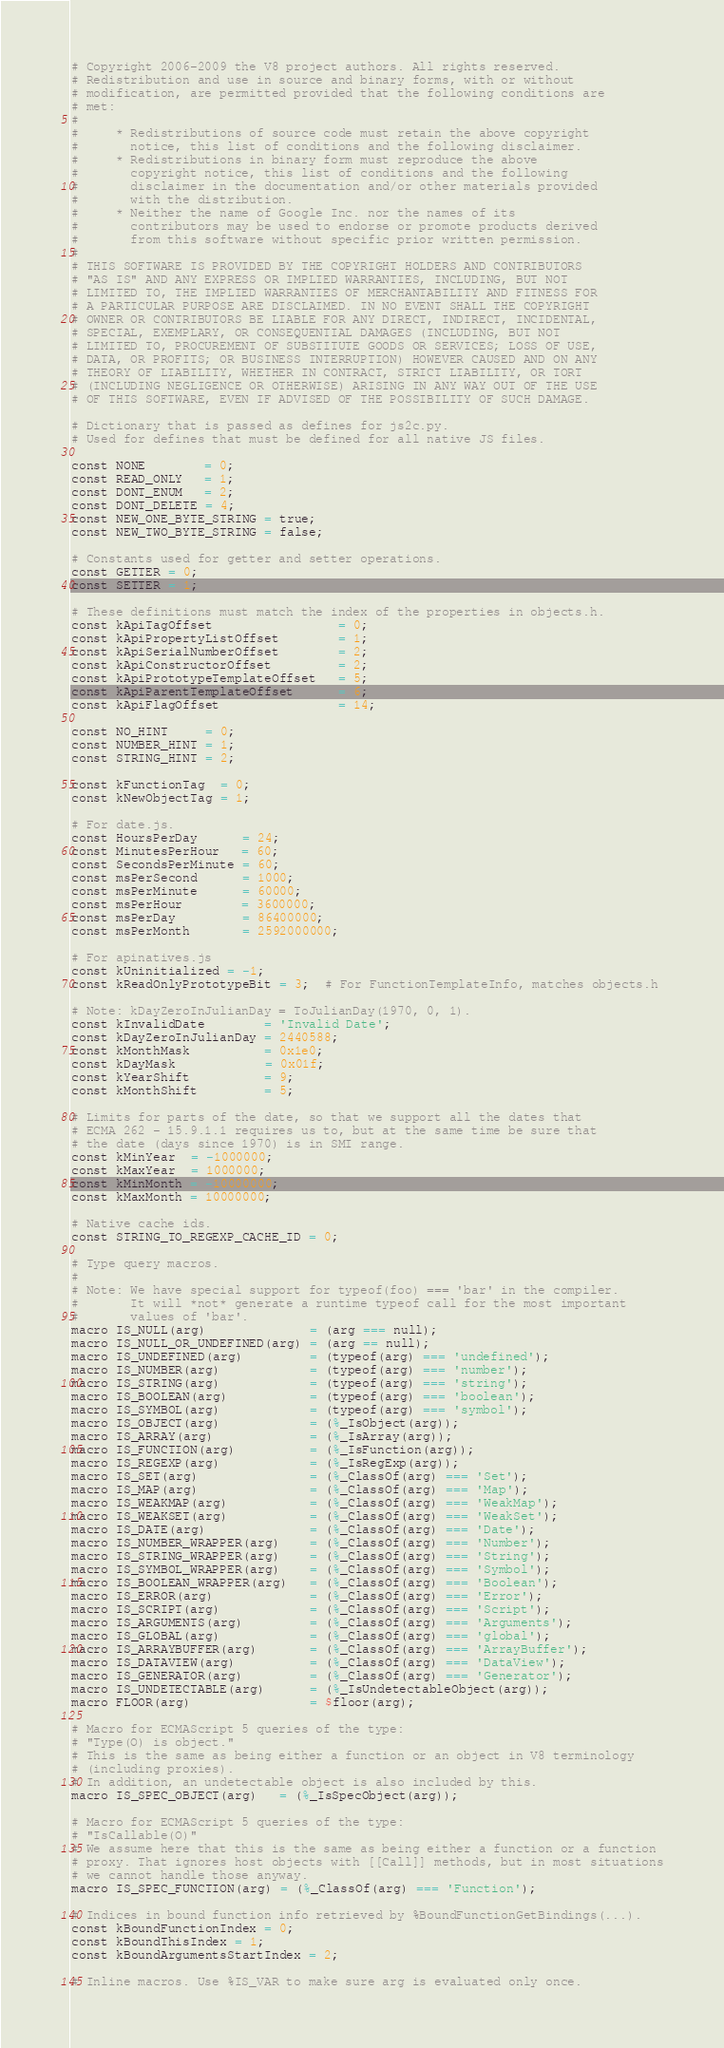<code> <loc_0><loc_0><loc_500><loc_500><_Python_># Copyright 2006-2009 the V8 project authors. All rights reserved.
# Redistribution and use in source and binary forms, with or without
# modification, are permitted provided that the following conditions are
# met:
#
#     * Redistributions of source code must retain the above copyright
#       notice, this list of conditions and the following disclaimer.
#     * Redistributions in binary form must reproduce the above
#       copyright notice, this list of conditions and the following
#       disclaimer in the documentation and/or other materials provided
#       with the distribution.
#     * Neither the name of Google Inc. nor the names of its
#       contributors may be used to endorse or promote products derived
#       from this software without specific prior written permission.
#
# THIS SOFTWARE IS PROVIDED BY THE COPYRIGHT HOLDERS AND CONTRIBUTORS
# "AS IS" AND ANY EXPRESS OR IMPLIED WARRANTIES, INCLUDING, BUT NOT
# LIMITED TO, THE IMPLIED WARRANTIES OF MERCHANTABILITY AND FITNESS FOR
# A PARTICULAR PURPOSE ARE DISCLAIMED. IN NO EVENT SHALL THE COPYRIGHT
# OWNER OR CONTRIBUTORS BE LIABLE FOR ANY DIRECT, INDIRECT, INCIDENTAL,
# SPECIAL, EXEMPLARY, OR CONSEQUENTIAL DAMAGES (INCLUDING, BUT NOT
# LIMITED TO, PROCUREMENT OF SUBSTITUTE GOODS OR SERVICES; LOSS OF USE,
# DATA, OR PROFITS; OR BUSINESS INTERRUPTION) HOWEVER CAUSED AND ON ANY
# THEORY OF LIABILITY, WHETHER IN CONTRACT, STRICT LIABILITY, OR TORT
# (INCLUDING NEGLIGENCE OR OTHERWISE) ARISING IN ANY WAY OUT OF THE USE
# OF THIS SOFTWARE, EVEN IF ADVISED OF THE POSSIBILITY OF SUCH DAMAGE.

# Dictionary that is passed as defines for js2c.py.
# Used for defines that must be defined for all native JS files.

const NONE        = 0;
const READ_ONLY   = 1;
const DONT_ENUM   = 2;
const DONT_DELETE = 4;
const NEW_ONE_BYTE_STRING = true;
const NEW_TWO_BYTE_STRING = false;

# Constants used for getter and setter operations.
const GETTER = 0;
const SETTER = 1;

# These definitions must match the index of the properties in objects.h.
const kApiTagOffset                 = 0;
const kApiPropertyListOffset        = 1;
const kApiSerialNumberOffset        = 2;
const kApiConstructorOffset         = 2;
const kApiPrototypeTemplateOffset   = 5;
const kApiParentTemplateOffset      = 6;
const kApiFlagOffset                = 14;

const NO_HINT     = 0;
const NUMBER_HINT = 1;
const STRING_HINT = 2;

const kFunctionTag  = 0;
const kNewObjectTag = 1;

# For date.js.
const HoursPerDay      = 24;
const MinutesPerHour   = 60;
const SecondsPerMinute = 60;
const msPerSecond      = 1000;
const msPerMinute      = 60000;
const msPerHour        = 3600000;
const msPerDay         = 86400000;
const msPerMonth       = 2592000000;

# For apinatives.js
const kUninitialized = -1;
const kReadOnlyPrototypeBit = 3;  # For FunctionTemplateInfo, matches objects.h

# Note: kDayZeroInJulianDay = ToJulianDay(1970, 0, 1).
const kInvalidDate        = 'Invalid Date';
const kDayZeroInJulianDay = 2440588;
const kMonthMask          = 0x1e0;
const kDayMask            = 0x01f;
const kYearShift          = 9;
const kMonthShift         = 5;

# Limits for parts of the date, so that we support all the dates that
# ECMA 262 - 15.9.1.1 requires us to, but at the same time be sure that
# the date (days since 1970) is in SMI range.
const kMinYear  = -1000000;
const kMaxYear  = 1000000;
const kMinMonth = -10000000;
const kMaxMonth = 10000000;

# Native cache ids.
const STRING_TO_REGEXP_CACHE_ID = 0;

# Type query macros.
#
# Note: We have special support for typeof(foo) === 'bar' in the compiler.
#       It will *not* generate a runtime typeof call for the most important
#       values of 'bar'.
macro IS_NULL(arg)              = (arg === null);
macro IS_NULL_OR_UNDEFINED(arg) = (arg == null);
macro IS_UNDEFINED(arg)         = (typeof(arg) === 'undefined');
macro IS_NUMBER(arg)            = (typeof(arg) === 'number');
macro IS_STRING(arg)            = (typeof(arg) === 'string');
macro IS_BOOLEAN(arg)           = (typeof(arg) === 'boolean');
macro IS_SYMBOL(arg)            = (typeof(arg) === 'symbol');
macro IS_OBJECT(arg)            = (%_IsObject(arg));
macro IS_ARRAY(arg)             = (%_IsArray(arg));
macro IS_FUNCTION(arg)          = (%_IsFunction(arg));
macro IS_REGEXP(arg)            = (%_IsRegExp(arg));
macro IS_SET(arg)               = (%_ClassOf(arg) === 'Set');
macro IS_MAP(arg)               = (%_ClassOf(arg) === 'Map');
macro IS_WEAKMAP(arg)           = (%_ClassOf(arg) === 'WeakMap');
macro IS_WEAKSET(arg)           = (%_ClassOf(arg) === 'WeakSet');
macro IS_DATE(arg)              = (%_ClassOf(arg) === 'Date');
macro IS_NUMBER_WRAPPER(arg)    = (%_ClassOf(arg) === 'Number');
macro IS_STRING_WRAPPER(arg)    = (%_ClassOf(arg) === 'String');
macro IS_SYMBOL_WRAPPER(arg)    = (%_ClassOf(arg) === 'Symbol');
macro IS_BOOLEAN_WRAPPER(arg)   = (%_ClassOf(arg) === 'Boolean');
macro IS_ERROR(arg)             = (%_ClassOf(arg) === 'Error');
macro IS_SCRIPT(arg)            = (%_ClassOf(arg) === 'Script');
macro IS_ARGUMENTS(arg)         = (%_ClassOf(arg) === 'Arguments');
macro IS_GLOBAL(arg)            = (%_ClassOf(arg) === 'global');
macro IS_ARRAYBUFFER(arg)       = (%_ClassOf(arg) === 'ArrayBuffer');
macro IS_DATAVIEW(arg)          = (%_ClassOf(arg) === 'DataView');
macro IS_GENERATOR(arg)         = (%_ClassOf(arg) === 'Generator');
macro IS_UNDETECTABLE(arg)      = (%_IsUndetectableObject(arg));
macro FLOOR(arg)                = $floor(arg);

# Macro for ECMAScript 5 queries of the type:
# "Type(O) is object."
# This is the same as being either a function or an object in V8 terminology
# (including proxies).
# In addition, an undetectable object is also included by this.
macro IS_SPEC_OBJECT(arg)   = (%_IsSpecObject(arg));

# Macro for ECMAScript 5 queries of the type:
# "IsCallable(O)"
# We assume here that this is the same as being either a function or a function
# proxy. That ignores host objects with [[Call]] methods, but in most situations
# we cannot handle those anyway.
macro IS_SPEC_FUNCTION(arg) = (%_ClassOf(arg) === 'Function');

# Indices in bound function info retrieved by %BoundFunctionGetBindings(...).
const kBoundFunctionIndex = 0;
const kBoundThisIndex = 1;
const kBoundArgumentsStartIndex = 2;

# Inline macros. Use %IS_VAR to make sure arg is evaluated only once.</code> 